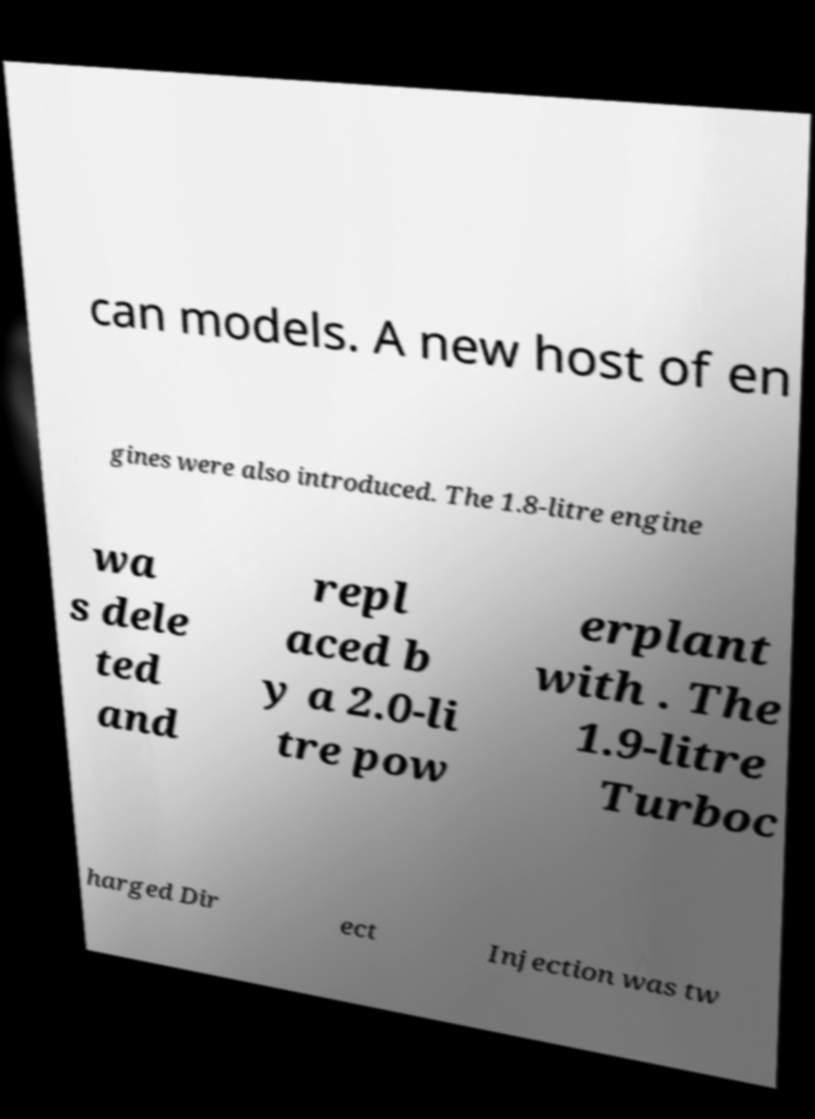Could you assist in decoding the text presented in this image and type it out clearly? can models. A new host of en gines were also introduced. The 1.8-litre engine wa s dele ted and repl aced b y a 2.0-li tre pow erplant with . The 1.9-litre Turboc harged Dir ect Injection was tw 